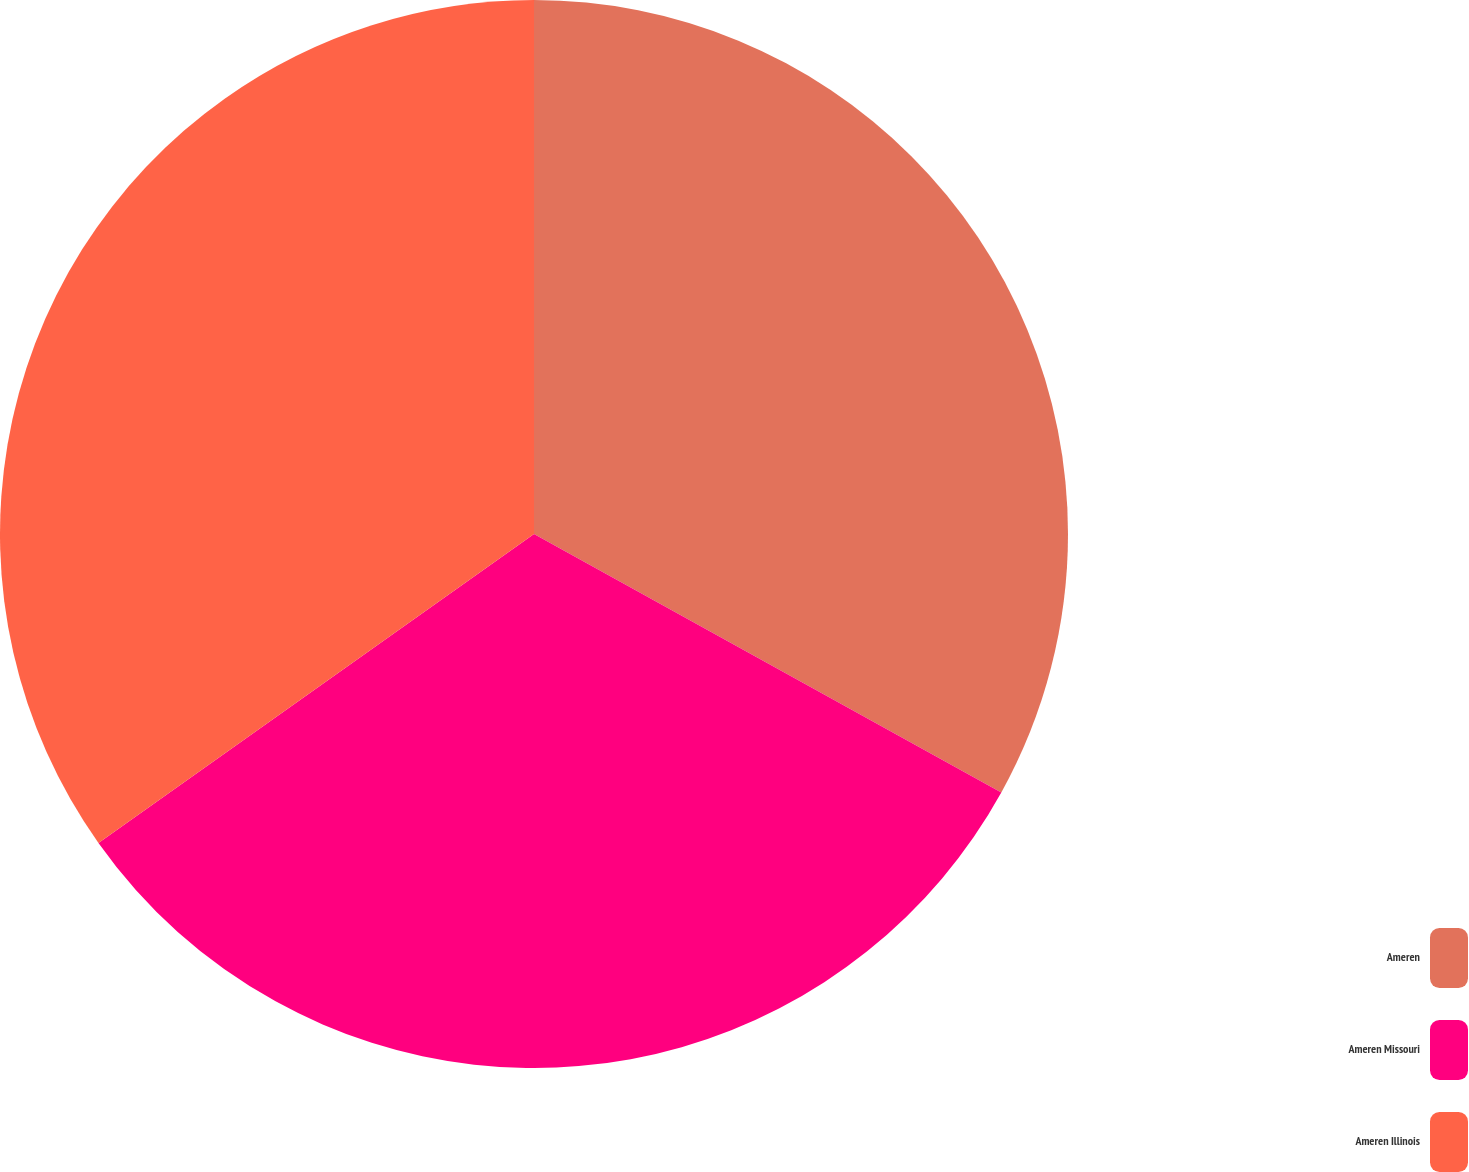Convert chart to OTSL. <chart><loc_0><loc_0><loc_500><loc_500><pie_chart><fcel>Ameren<fcel>Ameren Missouri<fcel>Ameren Illinois<nl><fcel>33.04%<fcel>32.14%<fcel>34.82%<nl></chart> 